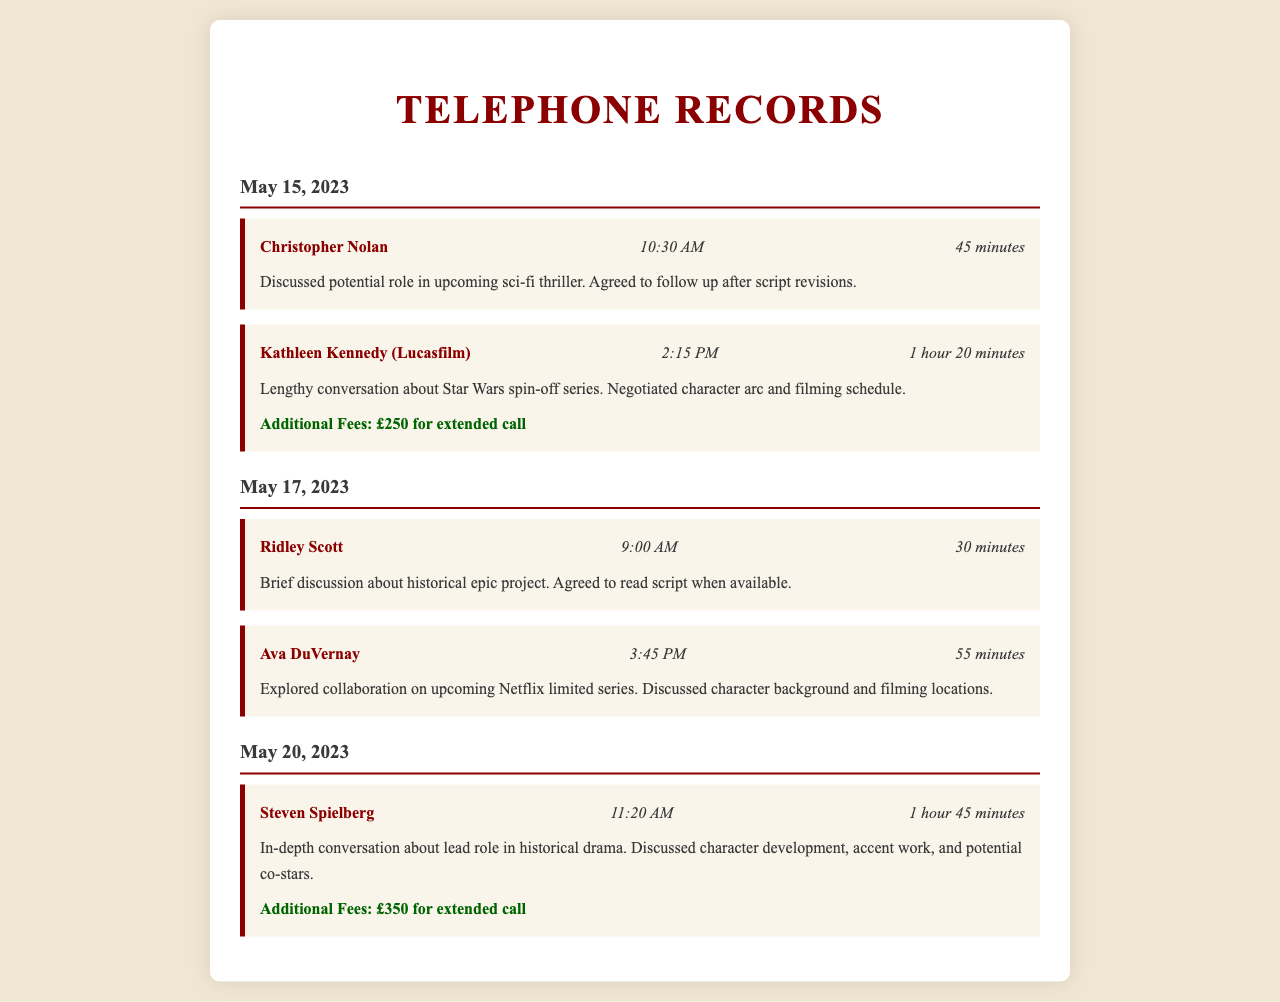what is the date of the conversation with Christopher Nolan? The date is specified under the header for his call in the document.
Answer: May 15, 2023 how long was the call with Kathleen Kennedy? The duration is noted in the call details for Kathleen Kennedy.
Answer: 1 hour 20 minutes what additional fee was incurred during the call with Steven Spielberg? The additional fees are listed in the call details for Steven Spielberg.
Answer: £350 for extended call who was discussed in relation to the upcoming Netflix limited series? The call with Ava DuVernay indicates a collaboration regarding character background.
Answer: Ava DuVernay when did the call with Ridley Scott take place? The time is provided in the call details for Ridley Scott.
Answer: 9:00 AM what was a major topic in the call with Christopher Nolan? The notes section offers insight into the subjects discussed during his call.
Answer: Potential role in upcoming sci-fi thriller how many minutes was the total duration of calls on May 15, 2023? You would need to sum the durations of the calls on that date as indicated.
Answer: 105 minutes which director's call included a discussion about character development? The discussions regarding character development are highlighted in Steven Spielberg's call notes.
Answer: Steven Spielberg 